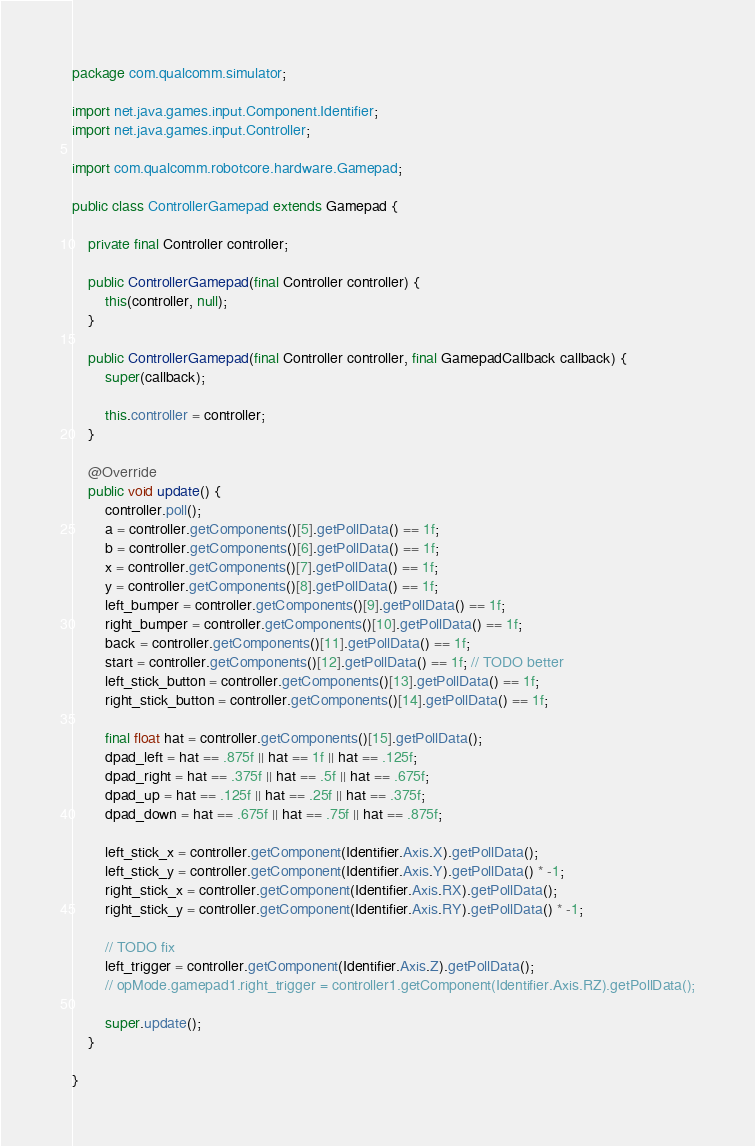Convert code to text. <code><loc_0><loc_0><loc_500><loc_500><_Java_>package com.qualcomm.simulator;

import net.java.games.input.Component.Identifier;
import net.java.games.input.Controller;

import com.qualcomm.robotcore.hardware.Gamepad;

public class ControllerGamepad extends Gamepad {

	private final Controller controller;

	public ControllerGamepad(final Controller controller) {
		this(controller, null);
	}

	public ControllerGamepad(final Controller controller, final GamepadCallback callback) {
		super(callback);

		this.controller = controller;
	}

	@Override
	public void update() {
		controller.poll();
		a = controller.getComponents()[5].getPollData() == 1f;
		b = controller.getComponents()[6].getPollData() == 1f;
		x = controller.getComponents()[7].getPollData() == 1f;
		y = controller.getComponents()[8].getPollData() == 1f;
		left_bumper = controller.getComponents()[9].getPollData() == 1f;
		right_bumper = controller.getComponents()[10].getPollData() == 1f;
		back = controller.getComponents()[11].getPollData() == 1f;
		start = controller.getComponents()[12].getPollData() == 1f; // TODO better
		left_stick_button = controller.getComponents()[13].getPollData() == 1f;
		right_stick_button = controller.getComponents()[14].getPollData() == 1f;

		final float hat = controller.getComponents()[15].getPollData();
		dpad_left = hat == .875f || hat == 1f || hat == .125f;
		dpad_right = hat == .375f || hat == .5f || hat == .675f;
		dpad_up = hat == .125f || hat == .25f || hat == .375f;
		dpad_down = hat == .675f || hat == .75f || hat == .875f;

		left_stick_x = controller.getComponent(Identifier.Axis.X).getPollData();
		left_stick_y = controller.getComponent(Identifier.Axis.Y).getPollData() * -1;
		right_stick_x = controller.getComponent(Identifier.Axis.RX).getPollData();
		right_stick_y = controller.getComponent(Identifier.Axis.RY).getPollData() * -1;

		// TODO fix
		left_trigger = controller.getComponent(Identifier.Axis.Z).getPollData();
		// opMode.gamepad1.right_trigger = controller1.getComponent(Identifier.Axis.RZ).getPollData();

		super.update();
	}

}
</code> 